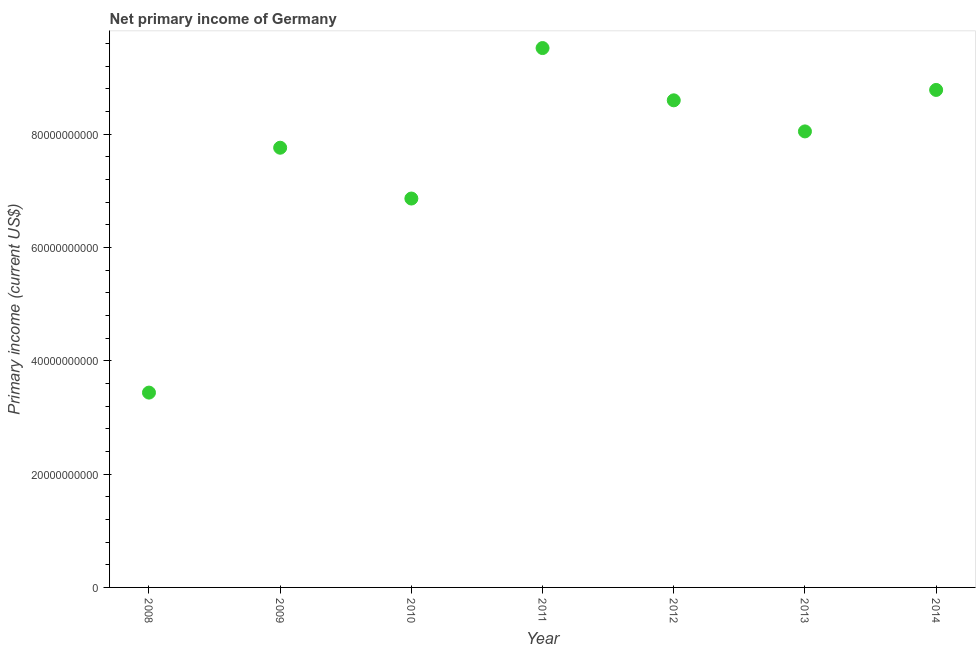What is the amount of primary income in 2011?
Keep it short and to the point. 9.52e+1. Across all years, what is the maximum amount of primary income?
Your answer should be compact. 9.52e+1. Across all years, what is the minimum amount of primary income?
Provide a short and direct response. 3.44e+1. What is the sum of the amount of primary income?
Ensure brevity in your answer.  5.30e+11. What is the difference between the amount of primary income in 2010 and 2011?
Provide a short and direct response. -2.66e+1. What is the average amount of primary income per year?
Your answer should be very brief. 7.57e+1. What is the median amount of primary income?
Offer a very short reply. 8.05e+1. Do a majority of the years between 2009 and 2013 (inclusive) have amount of primary income greater than 48000000000 US$?
Provide a succinct answer. Yes. What is the ratio of the amount of primary income in 2008 to that in 2013?
Your answer should be compact. 0.43. Is the amount of primary income in 2011 less than that in 2013?
Give a very brief answer. No. What is the difference between the highest and the second highest amount of primary income?
Your answer should be compact. 7.39e+09. What is the difference between the highest and the lowest amount of primary income?
Keep it short and to the point. 6.08e+1. How many dotlines are there?
Your answer should be very brief. 1. What is the difference between two consecutive major ticks on the Y-axis?
Your answer should be compact. 2.00e+1. Are the values on the major ticks of Y-axis written in scientific E-notation?
Offer a very short reply. No. Does the graph contain any zero values?
Offer a very short reply. No. What is the title of the graph?
Give a very brief answer. Net primary income of Germany. What is the label or title of the X-axis?
Offer a very short reply. Year. What is the label or title of the Y-axis?
Your answer should be very brief. Primary income (current US$). What is the Primary income (current US$) in 2008?
Your answer should be very brief. 3.44e+1. What is the Primary income (current US$) in 2009?
Your answer should be very brief. 7.76e+1. What is the Primary income (current US$) in 2010?
Your answer should be compact. 6.87e+1. What is the Primary income (current US$) in 2011?
Offer a terse response. 9.52e+1. What is the Primary income (current US$) in 2012?
Your response must be concise. 8.60e+1. What is the Primary income (current US$) in 2013?
Make the answer very short. 8.05e+1. What is the Primary income (current US$) in 2014?
Your answer should be very brief. 8.78e+1. What is the difference between the Primary income (current US$) in 2008 and 2009?
Keep it short and to the point. -4.32e+1. What is the difference between the Primary income (current US$) in 2008 and 2010?
Your answer should be very brief. -3.43e+1. What is the difference between the Primary income (current US$) in 2008 and 2011?
Make the answer very short. -6.08e+1. What is the difference between the Primary income (current US$) in 2008 and 2012?
Provide a short and direct response. -5.16e+1. What is the difference between the Primary income (current US$) in 2008 and 2013?
Your answer should be very brief. -4.61e+1. What is the difference between the Primary income (current US$) in 2008 and 2014?
Make the answer very short. -5.34e+1. What is the difference between the Primary income (current US$) in 2009 and 2010?
Give a very brief answer. 8.97e+09. What is the difference between the Primary income (current US$) in 2009 and 2011?
Give a very brief answer. -1.76e+1. What is the difference between the Primary income (current US$) in 2009 and 2012?
Offer a terse response. -8.37e+09. What is the difference between the Primary income (current US$) in 2009 and 2013?
Give a very brief answer. -2.88e+09. What is the difference between the Primary income (current US$) in 2009 and 2014?
Keep it short and to the point. -1.02e+1. What is the difference between the Primary income (current US$) in 2010 and 2011?
Offer a terse response. -2.66e+1. What is the difference between the Primary income (current US$) in 2010 and 2012?
Keep it short and to the point. -1.73e+1. What is the difference between the Primary income (current US$) in 2010 and 2013?
Offer a very short reply. -1.19e+1. What is the difference between the Primary income (current US$) in 2010 and 2014?
Provide a short and direct response. -1.92e+1. What is the difference between the Primary income (current US$) in 2011 and 2012?
Your response must be concise. 9.23e+09. What is the difference between the Primary income (current US$) in 2011 and 2013?
Make the answer very short. 1.47e+1. What is the difference between the Primary income (current US$) in 2011 and 2014?
Your response must be concise. 7.39e+09. What is the difference between the Primary income (current US$) in 2012 and 2013?
Your answer should be compact. 5.49e+09. What is the difference between the Primary income (current US$) in 2012 and 2014?
Your answer should be compact. -1.83e+09. What is the difference between the Primary income (current US$) in 2013 and 2014?
Offer a terse response. -7.32e+09. What is the ratio of the Primary income (current US$) in 2008 to that in 2009?
Offer a terse response. 0.44. What is the ratio of the Primary income (current US$) in 2008 to that in 2010?
Offer a terse response. 0.5. What is the ratio of the Primary income (current US$) in 2008 to that in 2011?
Your answer should be compact. 0.36. What is the ratio of the Primary income (current US$) in 2008 to that in 2013?
Offer a very short reply. 0.43. What is the ratio of the Primary income (current US$) in 2008 to that in 2014?
Ensure brevity in your answer.  0.39. What is the ratio of the Primary income (current US$) in 2009 to that in 2010?
Offer a very short reply. 1.13. What is the ratio of the Primary income (current US$) in 2009 to that in 2011?
Offer a terse response. 0.81. What is the ratio of the Primary income (current US$) in 2009 to that in 2012?
Provide a short and direct response. 0.9. What is the ratio of the Primary income (current US$) in 2009 to that in 2014?
Make the answer very short. 0.88. What is the ratio of the Primary income (current US$) in 2010 to that in 2011?
Make the answer very short. 0.72. What is the ratio of the Primary income (current US$) in 2010 to that in 2012?
Provide a short and direct response. 0.8. What is the ratio of the Primary income (current US$) in 2010 to that in 2013?
Your answer should be very brief. 0.85. What is the ratio of the Primary income (current US$) in 2010 to that in 2014?
Give a very brief answer. 0.78. What is the ratio of the Primary income (current US$) in 2011 to that in 2012?
Offer a very short reply. 1.11. What is the ratio of the Primary income (current US$) in 2011 to that in 2013?
Provide a succinct answer. 1.18. What is the ratio of the Primary income (current US$) in 2011 to that in 2014?
Your answer should be compact. 1.08. What is the ratio of the Primary income (current US$) in 2012 to that in 2013?
Offer a very short reply. 1.07. What is the ratio of the Primary income (current US$) in 2013 to that in 2014?
Offer a very short reply. 0.92. 